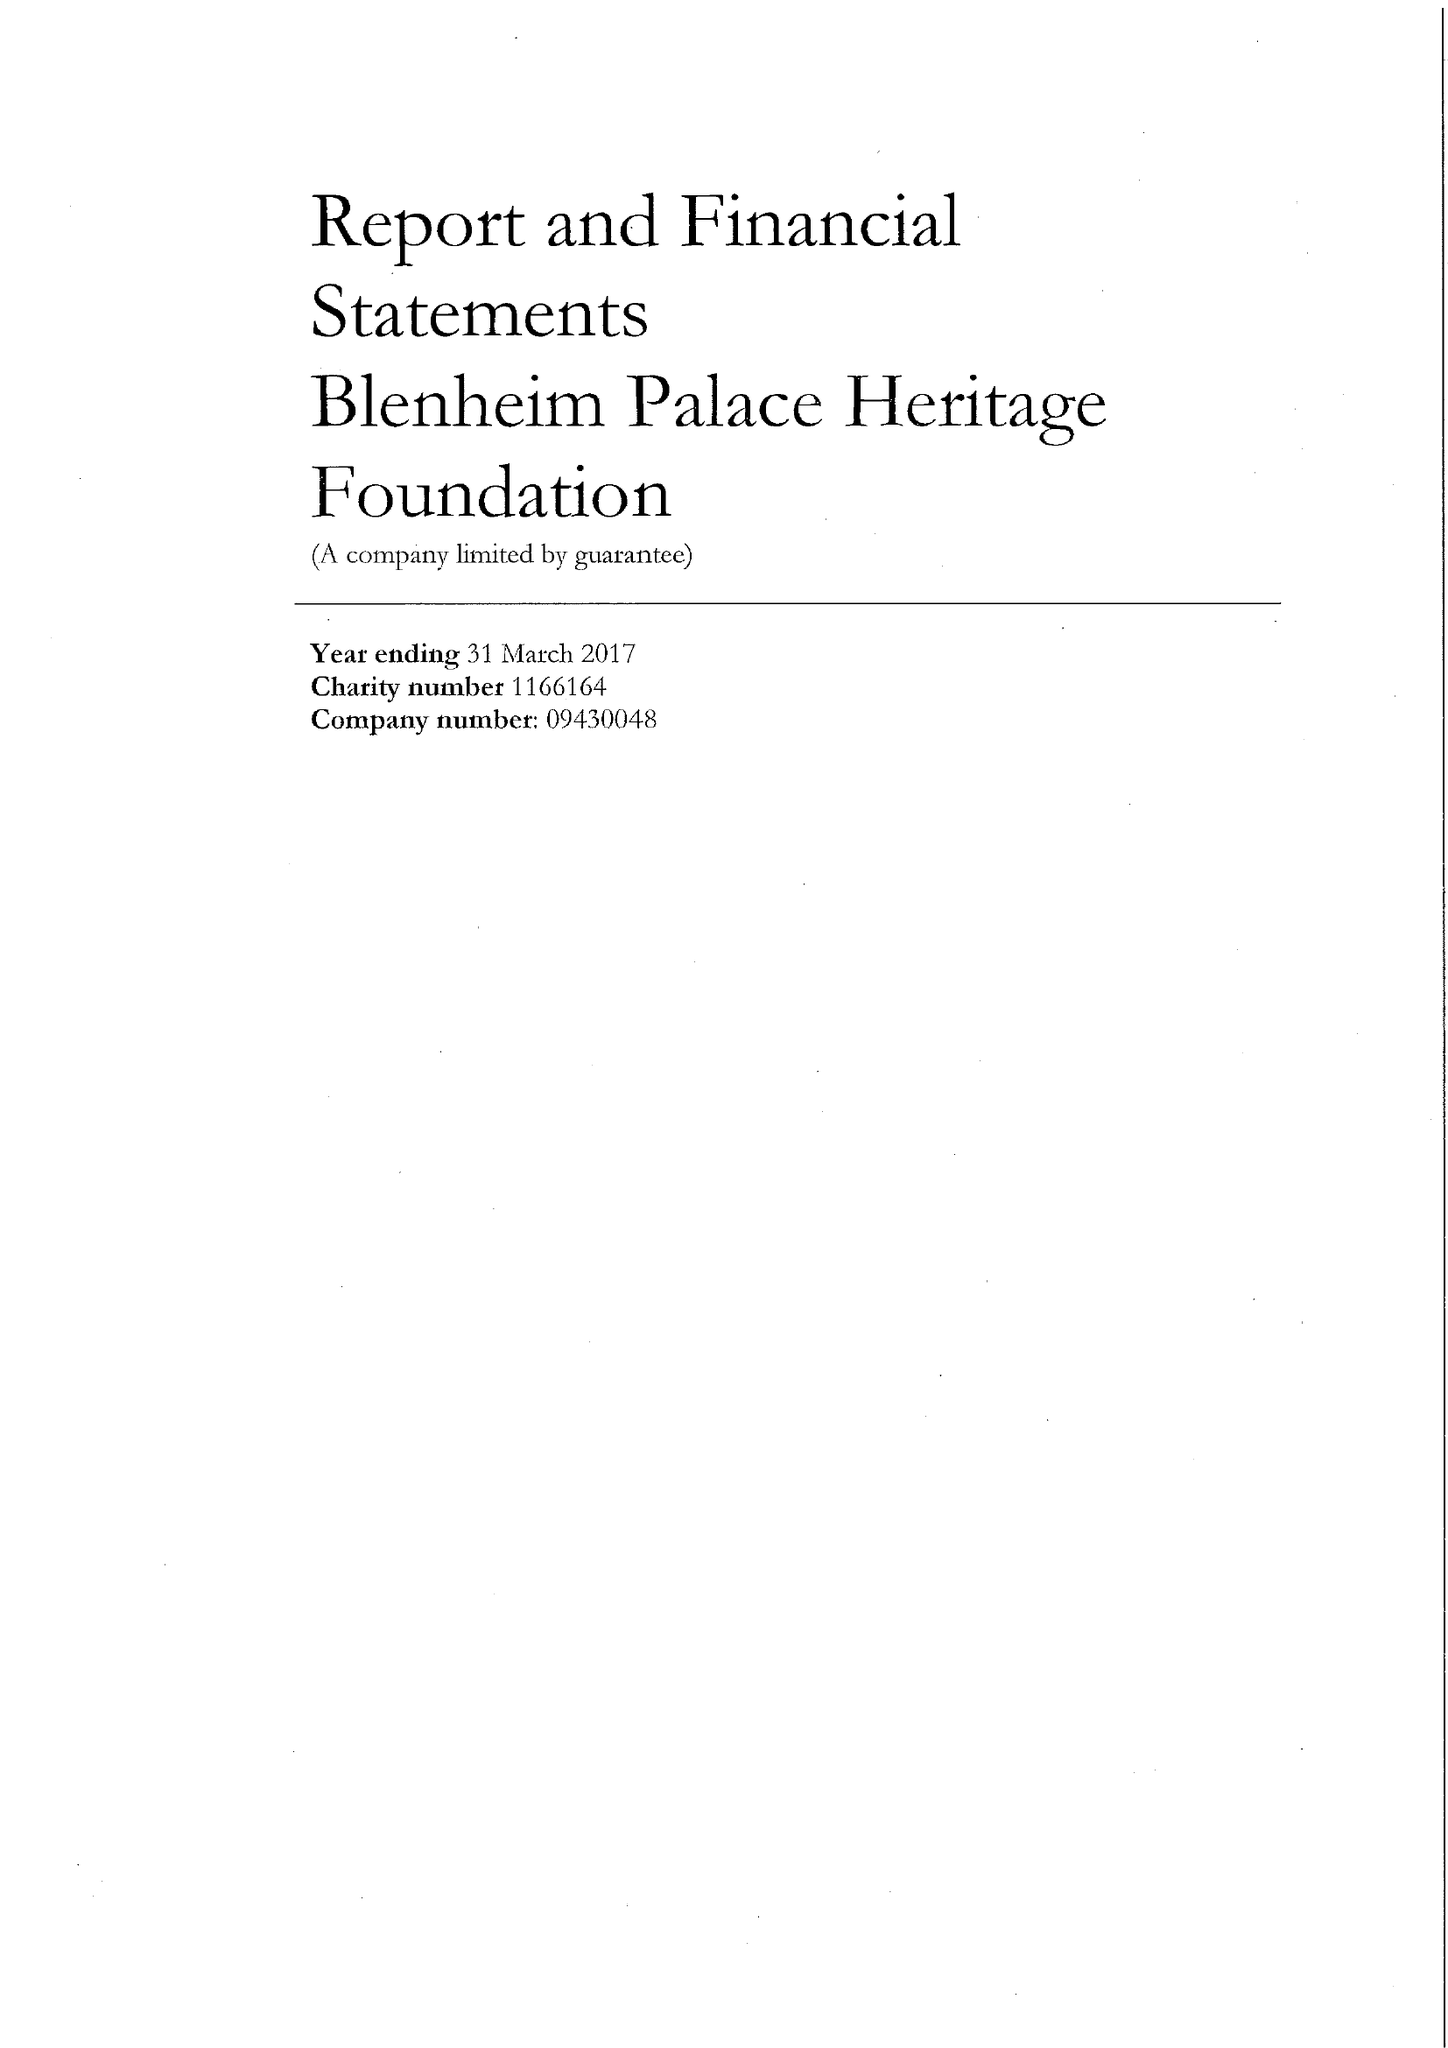What is the value for the charity_number?
Answer the question using a single word or phrase. 1166164 